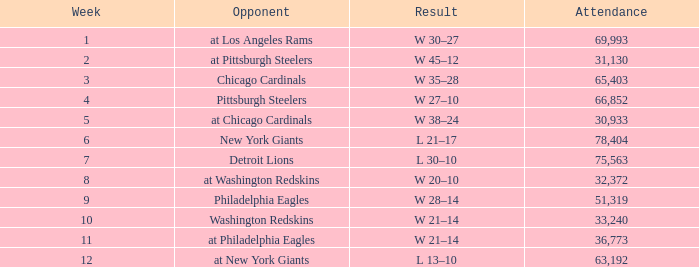What day had over 51,319 attending week 4? October 19, 1958. 